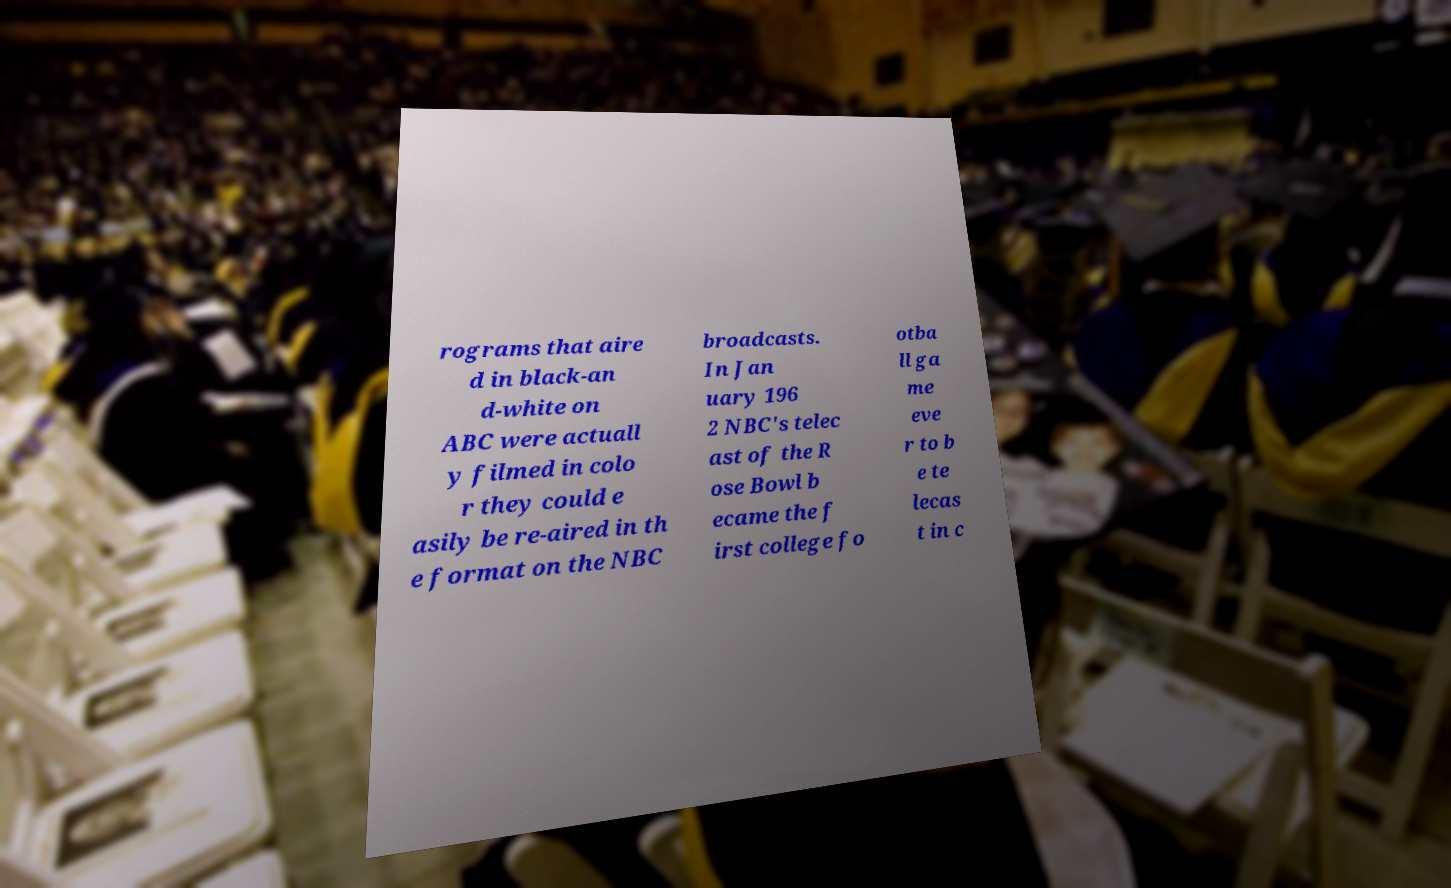Could you extract and type out the text from this image? rograms that aire d in black-an d-white on ABC were actuall y filmed in colo r they could e asily be re-aired in th e format on the NBC broadcasts. In Jan uary 196 2 NBC's telec ast of the R ose Bowl b ecame the f irst college fo otba ll ga me eve r to b e te lecas t in c 